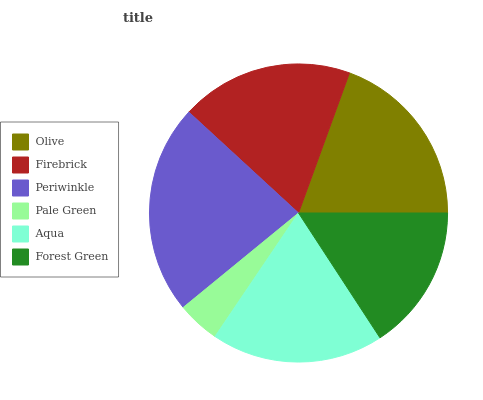Is Pale Green the minimum?
Answer yes or no. Yes. Is Periwinkle the maximum?
Answer yes or no. Yes. Is Firebrick the minimum?
Answer yes or no. No. Is Firebrick the maximum?
Answer yes or no. No. Is Olive greater than Firebrick?
Answer yes or no. Yes. Is Firebrick less than Olive?
Answer yes or no. Yes. Is Firebrick greater than Olive?
Answer yes or no. No. Is Olive less than Firebrick?
Answer yes or no. No. Is Firebrick the high median?
Answer yes or no. Yes. Is Aqua the low median?
Answer yes or no. Yes. Is Pale Green the high median?
Answer yes or no. No. Is Periwinkle the low median?
Answer yes or no. No. 